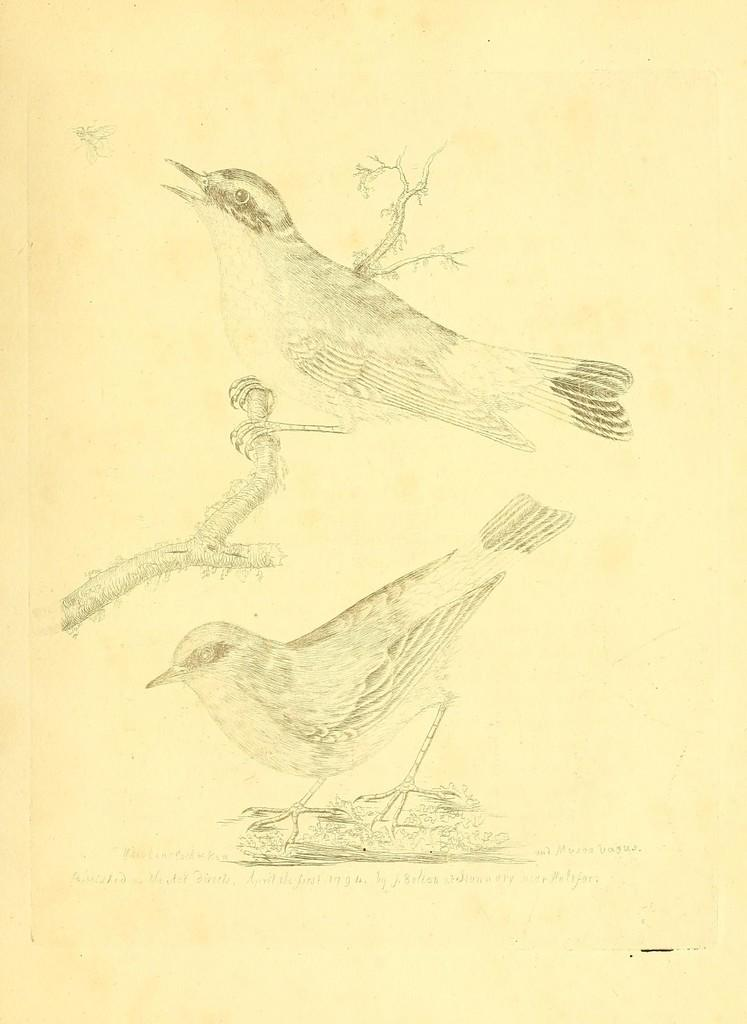What is depicted in the image? There is a drawing of pigeons in the image. Can you describe the scene in the drawing? A pigeon is sitting on a stem in the drawing. What is written at the bottom of the image? There is text written at the bottom of the image. How many lizards can be seen balancing on the rock in the image? There are no lizards or rocks present in the image; it features a drawing of pigeons with text at the bottom. 